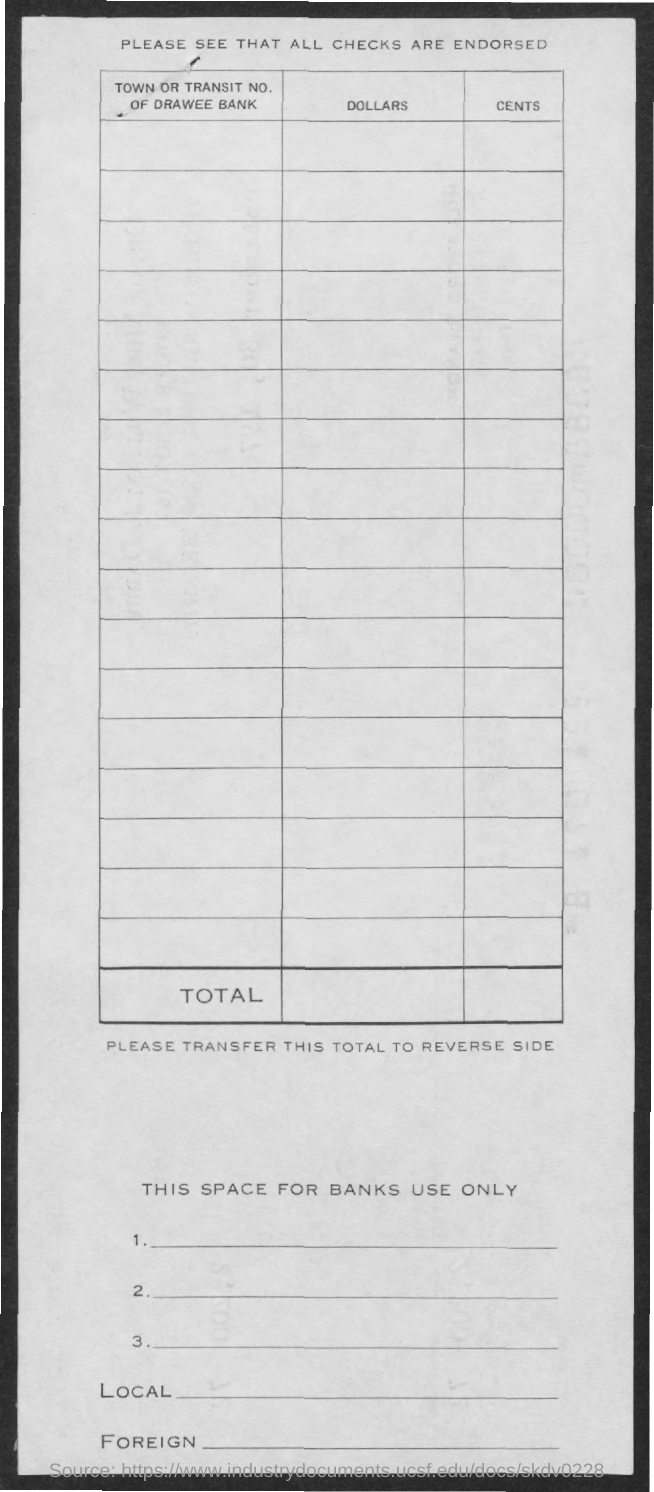What is the title of the document?
Give a very brief answer. Please see that all checks are endorsed. 